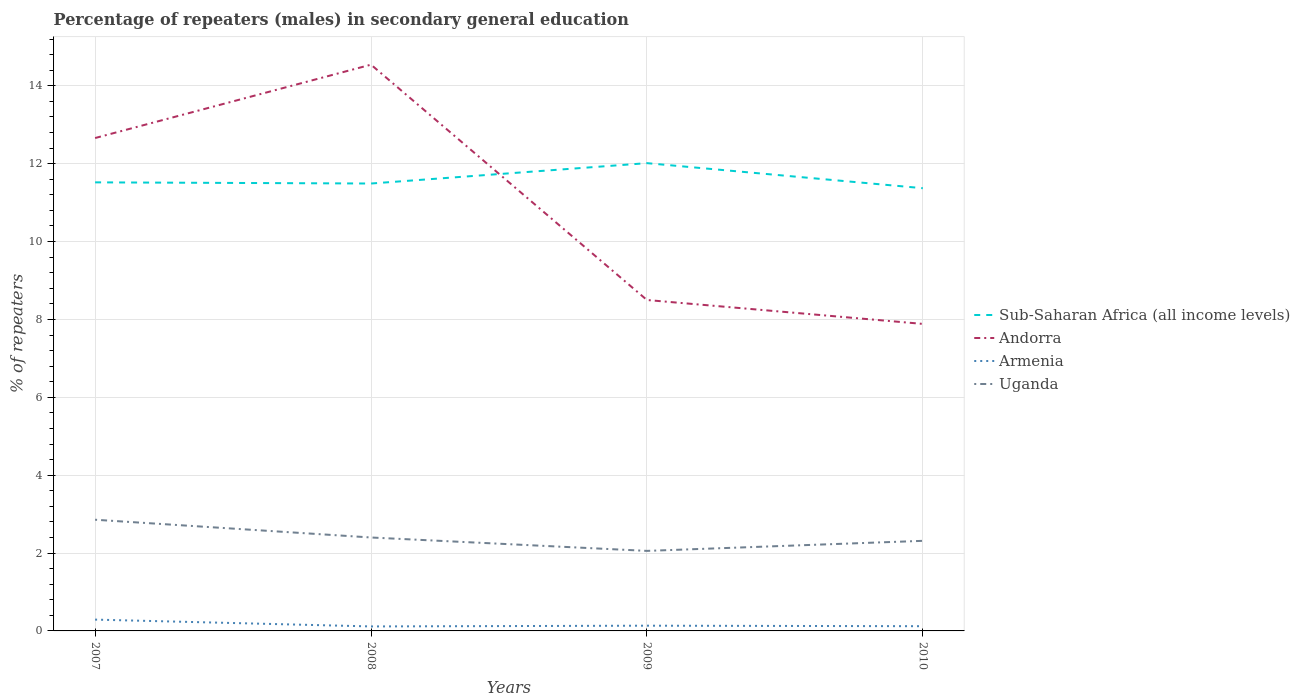How many different coloured lines are there?
Provide a succinct answer. 4. Across all years, what is the maximum percentage of male repeaters in Armenia?
Give a very brief answer. 0.12. What is the total percentage of male repeaters in Armenia in the graph?
Your answer should be compact. 0.17. What is the difference between the highest and the second highest percentage of male repeaters in Sub-Saharan Africa (all income levels)?
Provide a succinct answer. 0.64. What is the difference between the highest and the lowest percentage of male repeaters in Uganda?
Offer a very short reply. 1. Is the percentage of male repeaters in Sub-Saharan Africa (all income levels) strictly greater than the percentage of male repeaters in Andorra over the years?
Offer a very short reply. No. How many lines are there?
Ensure brevity in your answer.  4. What is the difference between two consecutive major ticks on the Y-axis?
Offer a very short reply. 2. Are the values on the major ticks of Y-axis written in scientific E-notation?
Your response must be concise. No. Where does the legend appear in the graph?
Offer a very short reply. Center right. What is the title of the graph?
Your answer should be very brief. Percentage of repeaters (males) in secondary general education. What is the label or title of the Y-axis?
Offer a very short reply. % of repeaters. What is the % of repeaters of Sub-Saharan Africa (all income levels) in 2007?
Make the answer very short. 11.52. What is the % of repeaters in Andorra in 2007?
Your answer should be compact. 12.66. What is the % of repeaters in Armenia in 2007?
Make the answer very short. 0.29. What is the % of repeaters of Uganda in 2007?
Your answer should be very brief. 2.86. What is the % of repeaters in Sub-Saharan Africa (all income levels) in 2008?
Your answer should be compact. 11.49. What is the % of repeaters of Andorra in 2008?
Ensure brevity in your answer.  14.54. What is the % of repeaters of Armenia in 2008?
Offer a terse response. 0.12. What is the % of repeaters of Uganda in 2008?
Your answer should be very brief. 2.4. What is the % of repeaters in Sub-Saharan Africa (all income levels) in 2009?
Keep it short and to the point. 12.01. What is the % of repeaters of Andorra in 2009?
Offer a very short reply. 8.5. What is the % of repeaters of Armenia in 2009?
Offer a very short reply. 0.13. What is the % of repeaters of Uganda in 2009?
Keep it short and to the point. 2.06. What is the % of repeaters in Sub-Saharan Africa (all income levels) in 2010?
Your response must be concise. 11.37. What is the % of repeaters in Andorra in 2010?
Make the answer very short. 7.89. What is the % of repeaters in Armenia in 2010?
Give a very brief answer. 0.12. What is the % of repeaters of Uganda in 2010?
Your response must be concise. 2.31. Across all years, what is the maximum % of repeaters in Sub-Saharan Africa (all income levels)?
Ensure brevity in your answer.  12.01. Across all years, what is the maximum % of repeaters of Andorra?
Your answer should be compact. 14.54. Across all years, what is the maximum % of repeaters in Armenia?
Your response must be concise. 0.29. Across all years, what is the maximum % of repeaters of Uganda?
Offer a terse response. 2.86. Across all years, what is the minimum % of repeaters of Sub-Saharan Africa (all income levels)?
Your response must be concise. 11.37. Across all years, what is the minimum % of repeaters in Andorra?
Keep it short and to the point. 7.89. Across all years, what is the minimum % of repeaters of Armenia?
Make the answer very short. 0.12. Across all years, what is the minimum % of repeaters of Uganda?
Your response must be concise. 2.06. What is the total % of repeaters of Sub-Saharan Africa (all income levels) in the graph?
Your answer should be compact. 46.4. What is the total % of repeaters of Andorra in the graph?
Your answer should be compact. 43.59. What is the total % of repeaters in Armenia in the graph?
Offer a terse response. 0.66. What is the total % of repeaters of Uganda in the graph?
Your response must be concise. 9.62. What is the difference between the % of repeaters of Sub-Saharan Africa (all income levels) in 2007 and that in 2008?
Your answer should be compact. 0.03. What is the difference between the % of repeaters of Andorra in 2007 and that in 2008?
Offer a very short reply. -1.88. What is the difference between the % of repeaters in Armenia in 2007 and that in 2008?
Your response must be concise. 0.18. What is the difference between the % of repeaters of Uganda in 2007 and that in 2008?
Offer a terse response. 0.46. What is the difference between the % of repeaters of Sub-Saharan Africa (all income levels) in 2007 and that in 2009?
Give a very brief answer. -0.49. What is the difference between the % of repeaters of Andorra in 2007 and that in 2009?
Give a very brief answer. 4.16. What is the difference between the % of repeaters in Armenia in 2007 and that in 2009?
Give a very brief answer. 0.16. What is the difference between the % of repeaters of Uganda in 2007 and that in 2009?
Provide a short and direct response. 0.8. What is the difference between the % of repeaters of Sub-Saharan Africa (all income levels) in 2007 and that in 2010?
Provide a short and direct response. 0.15. What is the difference between the % of repeaters of Andorra in 2007 and that in 2010?
Provide a short and direct response. 4.77. What is the difference between the % of repeaters of Armenia in 2007 and that in 2010?
Make the answer very short. 0.17. What is the difference between the % of repeaters of Uganda in 2007 and that in 2010?
Ensure brevity in your answer.  0.54. What is the difference between the % of repeaters in Sub-Saharan Africa (all income levels) in 2008 and that in 2009?
Your response must be concise. -0.52. What is the difference between the % of repeaters of Andorra in 2008 and that in 2009?
Offer a terse response. 6.04. What is the difference between the % of repeaters of Armenia in 2008 and that in 2009?
Your answer should be very brief. -0.02. What is the difference between the % of repeaters of Uganda in 2008 and that in 2009?
Provide a short and direct response. 0.34. What is the difference between the % of repeaters in Sub-Saharan Africa (all income levels) in 2008 and that in 2010?
Your answer should be compact. 0.12. What is the difference between the % of repeaters in Andorra in 2008 and that in 2010?
Keep it short and to the point. 6.66. What is the difference between the % of repeaters in Armenia in 2008 and that in 2010?
Your answer should be very brief. -0.01. What is the difference between the % of repeaters in Uganda in 2008 and that in 2010?
Provide a succinct answer. 0.09. What is the difference between the % of repeaters in Sub-Saharan Africa (all income levels) in 2009 and that in 2010?
Your response must be concise. 0.64. What is the difference between the % of repeaters in Andorra in 2009 and that in 2010?
Your answer should be very brief. 0.61. What is the difference between the % of repeaters of Armenia in 2009 and that in 2010?
Make the answer very short. 0.01. What is the difference between the % of repeaters in Uganda in 2009 and that in 2010?
Your answer should be compact. -0.26. What is the difference between the % of repeaters in Sub-Saharan Africa (all income levels) in 2007 and the % of repeaters in Andorra in 2008?
Ensure brevity in your answer.  -3.02. What is the difference between the % of repeaters in Sub-Saharan Africa (all income levels) in 2007 and the % of repeaters in Armenia in 2008?
Offer a terse response. 11.41. What is the difference between the % of repeaters in Sub-Saharan Africa (all income levels) in 2007 and the % of repeaters in Uganda in 2008?
Make the answer very short. 9.12. What is the difference between the % of repeaters in Andorra in 2007 and the % of repeaters in Armenia in 2008?
Ensure brevity in your answer.  12.54. What is the difference between the % of repeaters in Andorra in 2007 and the % of repeaters in Uganda in 2008?
Provide a short and direct response. 10.26. What is the difference between the % of repeaters in Armenia in 2007 and the % of repeaters in Uganda in 2008?
Provide a succinct answer. -2.11. What is the difference between the % of repeaters of Sub-Saharan Africa (all income levels) in 2007 and the % of repeaters of Andorra in 2009?
Provide a short and direct response. 3.02. What is the difference between the % of repeaters of Sub-Saharan Africa (all income levels) in 2007 and the % of repeaters of Armenia in 2009?
Your response must be concise. 11.39. What is the difference between the % of repeaters in Sub-Saharan Africa (all income levels) in 2007 and the % of repeaters in Uganda in 2009?
Your answer should be very brief. 9.47. What is the difference between the % of repeaters of Andorra in 2007 and the % of repeaters of Armenia in 2009?
Ensure brevity in your answer.  12.52. What is the difference between the % of repeaters in Andorra in 2007 and the % of repeaters in Uganda in 2009?
Keep it short and to the point. 10.6. What is the difference between the % of repeaters in Armenia in 2007 and the % of repeaters in Uganda in 2009?
Provide a short and direct response. -1.76. What is the difference between the % of repeaters in Sub-Saharan Africa (all income levels) in 2007 and the % of repeaters in Andorra in 2010?
Provide a succinct answer. 3.64. What is the difference between the % of repeaters in Sub-Saharan Africa (all income levels) in 2007 and the % of repeaters in Armenia in 2010?
Your response must be concise. 11.4. What is the difference between the % of repeaters in Sub-Saharan Africa (all income levels) in 2007 and the % of repeaters in Uganda in 2010?
Provide a succinct answer. 9.21. What is the difference between the % of repeaters in Andorra in 2007 and the % of repeaters in Armenia in 2010?
Provide a short and direct response. 12.54. What is the difference between the % of repeaters in Andorra in 2007 and the % of repeaters in Uganda in 2010?
Provide a succinct answer. 10.35. What is the difference between the % of repeaters in Armenia in 2007 and the % of repeaters in Uganda in 2010?
Ensure brevity in your answer.  -2.02. What is the difference between the % of repeaters of Sub-Saharan Africa (all income levels) in 2008 and the % of repeaters of Andorra in 2009?
Give a very brief answer. 2.99. What is the difference between the % of repeaters of Sub-Saharan Africa (all income levels) in 2008 and the % of repeaters of Armenia in 2009?
Ensure brevity in your answer.  11.36. What is the difference between the % of repeaters of Sub-Saharan Africa (all income levels) in 2008 and the % of repeaters of Uganda in 2009?
Your answer should be very brief. 9.44. What is the difference between the % of repeaters of Andorra in 2008 and the % of repeaters of Armenia in 2009?
Keep it short and to the point. 14.41. What is the difference between the % of repeaters of Andorra in 2008 and the % of repeaters of Uganda in 2009?
Ensure brevity in your answer.  12.49. What is the difference between the % of repeaters in Armenia in 2008 and the % of repeaters in Uganda in 2009?
Offer a very short reply. -1.94. What is the difference between the % of repeaters in Sub-Saharan Africa (all income levels) in 2008 and the % of repeaters in Andorra in 2010?
Keep it short and to the point. 3.61. What is the difference between the % of repeaters of Sub-Saharan Africa (all income levels) in 2008 and the % of repeaters of Armenia in 2010?
Your answer should be compact. 11.37. What is the difference between the % of repeaters of Sub-Saharan Africa (all income levels) in 2008 and the % of repeaters of Uganda in 2010?
Offer a very short reply. 9.18. What is the difference between the % of repeaters of Andorra in 2008 and the % of repeaters of Armenia in 2010?
Keep it short and to the point. 14.42. What is the difference between the % of repeaters in Andorra in 2008 and the % of repeaters in Uganda in 2010?
Ensure brevity in your answer.  12.23. What is the difference between the % of repeaters of Armenia in 2008 and the % of repeaters of Uganda in 2010?
Make the answer very short. -2.2. What is the difference between the % of repeaters of Sub-Saharan Africa (all income levels) in 2009 and the % of repeaters of Andorra in 2010?
Offer a terse response. 4.13. What is the difference between the % of repeaters in Sub-Saharan Africa (all income levels) in 2009 and the % of repeaters in Armenia in 2010?
Offer a terse response. 11.89. What is the difference between the % of repeaters of Sub-Saharan Africa (all income levels) in 2009 and the % of repeaters of Uganda in 2010?
Offer a very short reply. 9.7. What is the difference between the % of repeaters of Andorra in 2009 and the % of repeaters of Armenia in 2010?
Your response must be concise. 8.38. What is the difference between the % of repeaters of Andorra in 2009 and the % of repeaters of Uganda in 2010?
Keep it short and to the point. 6.19. What is the difference between the % of repeaters in Armenia in 2009 and the % of repeaters in Uganda in 2010?
Ensure brevity in your answer.  -2.18. What is the average % of repeaters of Sub-Saharan Africa (all income levels) per year?
Offer a terse response. 11.6. What is the average % of repeaters of Andorra per year?
Provide a succinct answer. 10.9. What is the average % of repeaters in Armenia per year?
Offer a terse response. 0.17. What is the average % of repeaters in Uganda per year?
Provide a short and direct response. 2.41. In the year 2007, what is the difference between the % of repeaters in Sub-Saharan Africa (all income levels) and % of repeaters in Andorra?
Your answer should be very brief. -1.14. In the year 2007, what is the difference between the % of repeaters in Sub-Saharan Africa (all income levels) and % of repeaters in Armenia?
Your answer should be compact. 11.23. In the year 2007, what is the difference between the % of repeaters of Sub-Saharan Africa (all income levels) and % of repeaters of Uganda?
Give a very brief answer. 8.66. In the year 2007, what is the difference between the % of repeaters in Andorra and % of repeaters in Armenia?
Your answer should be compact. 12.37. In the year 2007, what is the difference between the % of repeaters in Andorra and % of repeaters in Uganda?
Your answer should be compact. 9.8. In the year 2007, what is the difference between the % of repeaters in Armenia and % of repeaters in Uganda?
Provide a succinct answer. -2.57. In the year 2008, what is the difference between the % of repeaters of Sub-Saharan Africa (all income levels) and % of repeaters of Andorra?
Offer a very short reply. -3.05. In the year 2008, what is the difference between the % of repeaters in Sub-Saharan Africa (all income levels) and % of repeaters in Armenia?
Keep it short and to the point. 11.38. In the year 2008, what is the difference between the % of repeaters in Sub-Saharan Africa (all income levels) and % of repeaters in Uganda?
Your answer should be compact. 9.09. In the year 2008, what is the difference between the % of repeaters of Andorra and % of repeaters of Armenia?
Your answer should be compact. 14.43. In the year 2008, what is the difference between the % of repeaters of Andorra and % of repeaters of Uganda?
Your answer should be very brief. 12.14. In the year 2008, what is the difference between the % of repeaters in Armenia and % of repeaters in Uganda?
Your answer should be compact. -2.28. In the year 2009, what is the difference between the % of repeaters in Sub-Saharan Africa (all income levels) and % of repeaters in Andorra?
Give a very brief answer. 3.52. In the year 2009, what is the difference between the % of repeaters of Sub-Saharan Africa (all income levels) and % of repeaters of Armenia?
Ensure brevity in your answer.  11.88. In the year 2009, what is the difference between the % of repeaters in Sub-Saharan Africa (all income levels) and % of repeaters in Uganda?
Make the answer very short. 9.96. In the year 2009, what is the difference between the % of repeaters in Andorra and % of repeaters in Armenia?
Your answer should be compact. 8.36. In the year 2009, what is the difference between the % of repeaters of Andorra and % of repeaters of Uganda?
Offer a terse response. 6.44. In the year 2009, what is the difference between the % of repeaters of Armenia and % of repeaters of Uganda?
Offer a terse response. -1.92. In the year 2010, what is the difference between the % of repeaters in Sub-Saharan Africa (all income levels) and % of repeaters in Andorra?
Keep it short and to the point. 3.49. In the year 2010, what is the difference between the % of repeaters of Sub-Saharan Africa (all income levels) and % of repeaters of Armenia?
Make the answer very short. 11.25. In the year 2010, what is the difference between the % of repeaters of Sub-Saharan Africa (all income levels) and % of repeaters of Uganda?
Offer a terse response. 9.06. In the year 2010, what is the difference between the % of repeaters in Andorra and % of repeaters in Armenia?
Keep it short and to the point. 7.76. In the year 2010, what is the difference between the % of repeaters of Andorra and % of repeaters of Uganda?
Keep it short and to the point. 5.57. In the year 2010, what is the difference between the % of repeaters in Armenia and % of repeaters in Uganda?
Your answer should be compact. -2.19. What is the ratio of the % of repeaters of Andorra in 2007 to that in 2008?
Offer a very short reply. 0.87. What is the ratio of the % of repeaters in Armenia in 2007 to that in 2008?
Keep it short and to the point. 2.52. What is the ratio of the % of repeaters of Uganda in 2007 to that in 2008?
Your answer should be very brief. 1.19. What is the ratio of the % of repeaters of Sub-Saharan Africa (all income levels) in 2007 to that in 2009?
Offer a terse response. 0.96. What is the ratio of the % of repeaters in Andorra in 2007 to that in 2009?
Provide a succinct answer. 1.49. What is the ratio of the % of repeaters in Armenia in 2007 to that in 2009?
Offer a terse response. 2.16. What is the ratio of the % of repeaters in Uganda in 2007 to that in 2009?
Offer a very short reply. 1.39. What is the ratio of the % of repeaters in Sub-Saharan Africa (all income levels) in 2007 to that in 2010?
Provide a succinct answer. 1.01. What is the ratio of the % of repeaters in Andorra in 2007 to that in 2010?
Your answer should be compact. 1.61. What is the ratio of the % of repeaters in Armenia in 2007 to that in 2010?
Offer a very short reply. 2.4. What is the ratio of the % of repeaters of Uganda in 2007 to that in 2010?
Provide a short and direct response. 1.23. What is the ratio of the % of repeaters in Sub-Saharan Africa (all income levels) in 2008 to that in 2009?
Keep it short and to the point. 0.96. What is the ratio of the % of repeaters in Andorra in 2008 to that in 2009?
Your answer should be very brief. 1.71. What is the ratio of the % of repeaters of Armenia in 2008 to that in 2009?
Your answer should be compact. 0.86. What is the ratio of the % of repeaters in Uganda in 2008 to that in 2009?
Ensure brevity in your answer.  1.17. What is the ratio of the % of repeaters of Sub-Saharan Africa (all income levels) in 2008 to that in 2010?
Provide a succinct answer. 1.01. What is the ratio of the % of repeaters in Andorra in 2008 to that in 2010?
Offer a very short reply. 1.84. What is the ratio of the % of repeaters of Armenia in 2008 to that in 2010?
Offer a very short reply. 0.95. What is the ratio of the % of repeaters of Uganda in 2008 to that in 2010?
Keep it short and to the point. 1.04. What is the ratio of the % of repeaters in Sub-Saharan Africa (all income levels) in 2009 to that in 2010?
Keep it short and to the point. 1.06. What is the ratio of the % of repeaters of Andorra in 2009 to that in 2010?
Ensure brevity in your answer.  1.08. What is the ratio of the % of repeaters of Armenia in 2009 to that in 2010?
Your answer should be compact. 1.11. What is the ratio of the % of repeaters of Uganda in 2009 to that in 2010?
Keep it short and to the point. 0.89. What is the difference between the highest and the second highest % of repeaters of Sub-Saharan Africa (all income levels)?
Your answer should be very brief. 0.49. What is the difference between the highest and the second highest % of repeaters in Andorra?
Your answer should be very brief. 1.88. What is the difference between the highest and the second highest % of repeaters in Armenia?
Your response must be concise. 0.16. What is the difference between the highest and the second highest % of repeaters of Uganda?
Your answer should be very brief. 0.46. What is the difference between the highest and the lowest % of repeaters in Sub-Saharan Africa (all income levels)?
Your response must be concise. 0.64. What is the difference between the highest and the lowest % of repeaters in Andorra?
Give a very brief answer. 6.66. What is the difference between the highest and the lowest % of repeaters of Armenia?
Ensure brevity in your answer.  0.18. What is the difference between the highest and the lowest % of repeaters of Uganda?
Your answer should be compact. 0.8. 